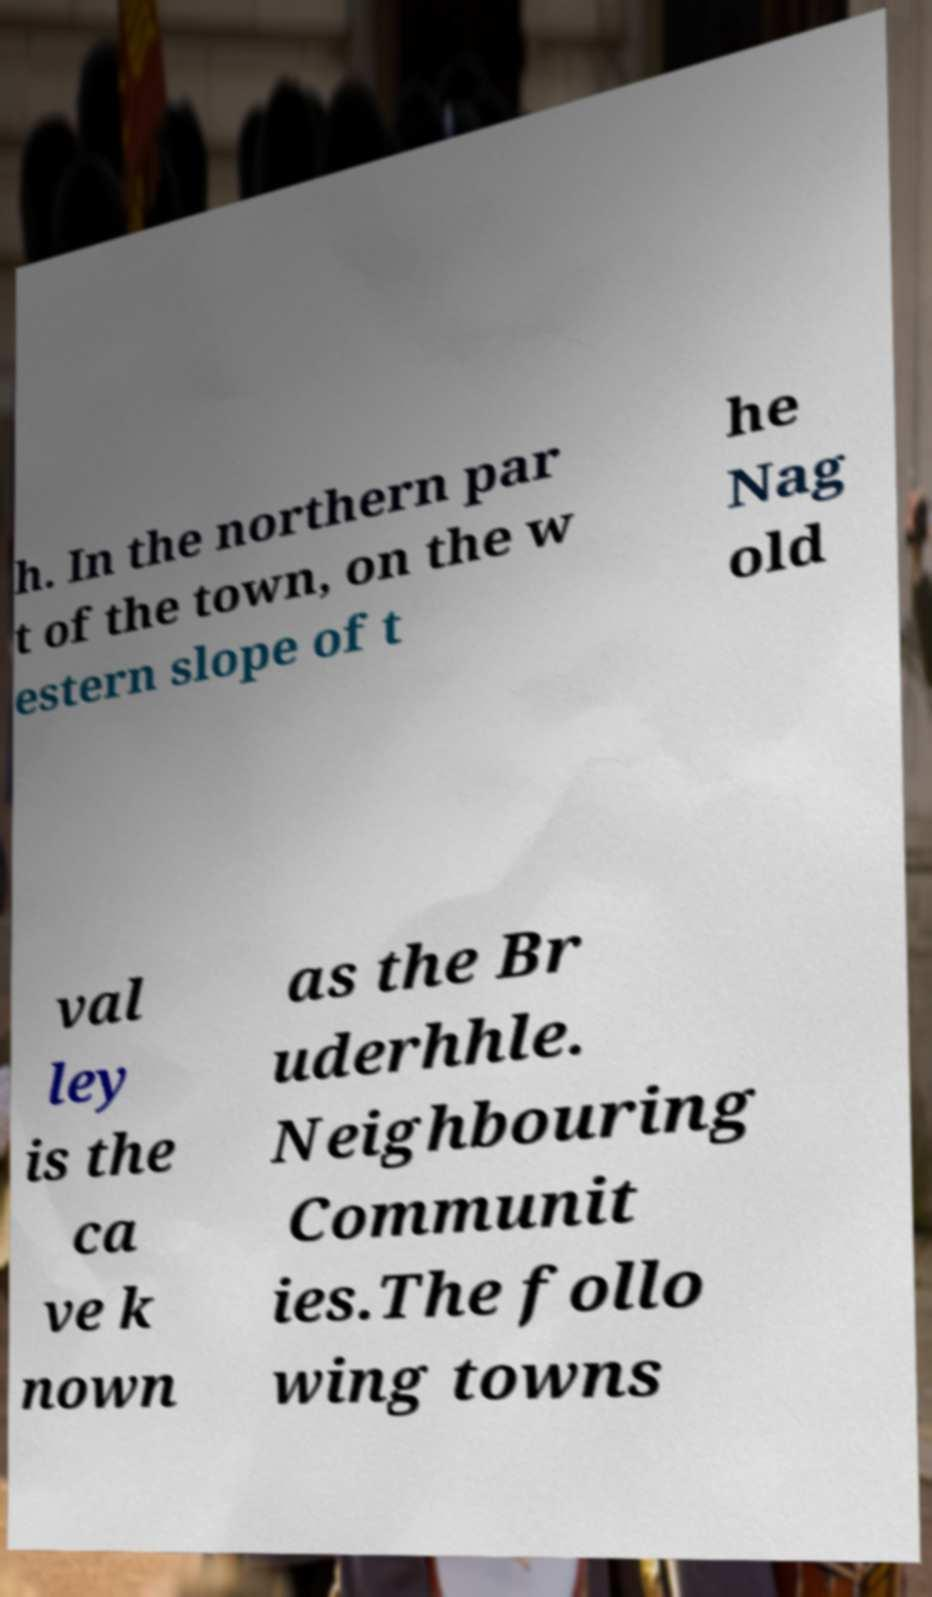For documentation purposes, I need the text within this image transcribed. Could you provide that? h. In the northern par t of the town, on the w estern slope of t he Nag old val ley is the ca ve k nown as the Br uderhhle. Neighbouring Communit ies.The follo wing towns 